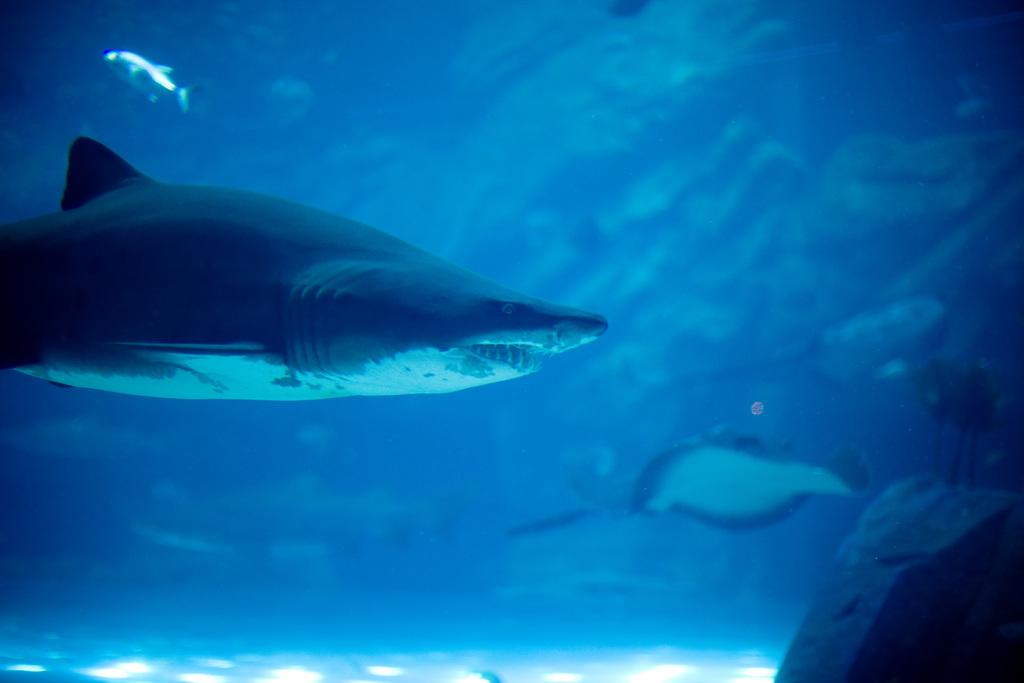What animals are present in the image? There are two fishes in the image. What is the environment in which the fishes are located? The fishes are in water. Can you describe the position of one of the fishes? One fish is facing towards the right side. What object can be seen in the bottom right corner of the image? There is a rock in the bottom right corner of the image. What type of line can be seen connecting the two fishes in the image? There is no line connecting the two fishes in the image. Is there a bridge visible in the image? No, there is no bridge present in the image. 